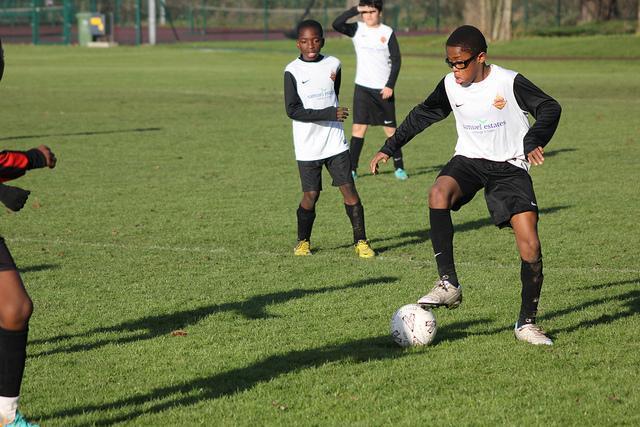How many people can you see?
Give a very brief answer. 4. 